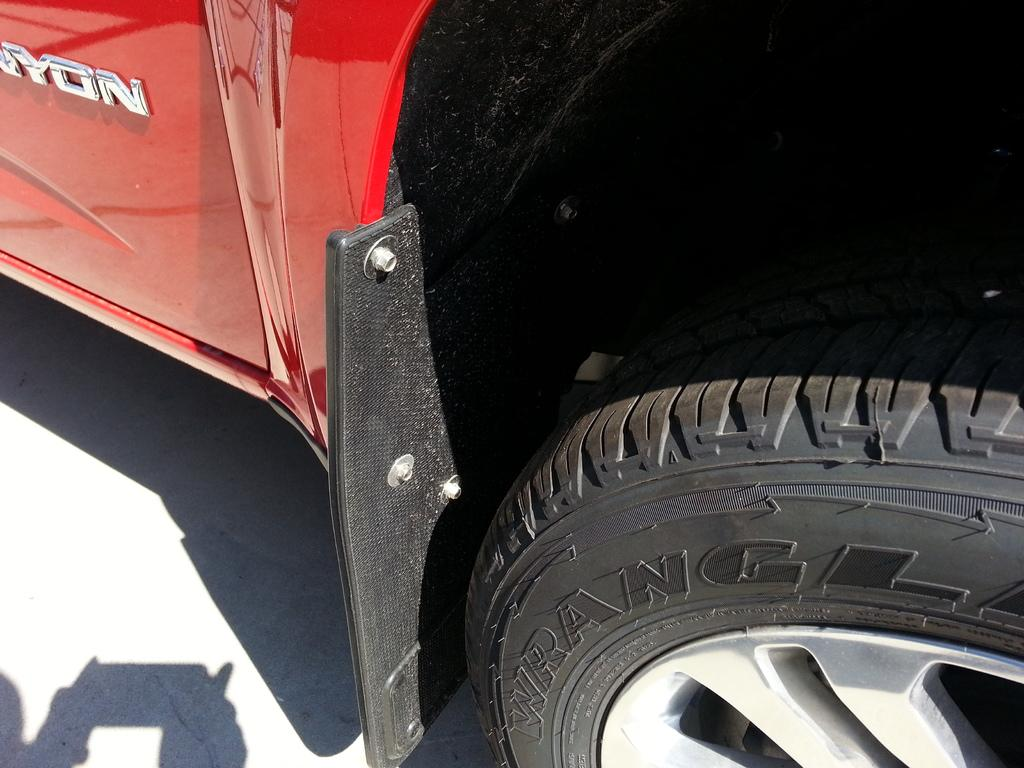What is the color of the vehicle in the image? The vehicle in the image is red. What is the color of the wheel in the image? The wheel in the image is black. Where is the vehicle located in the image? The vehicle is on the land in the image. What is the topic of the heated argument taking place in the image? There is no heated argument present in the image. 